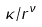Convert formula to latex. <formula><loc_0><loc_0><loc_500><loc_500>\kappa / r ^ { \nu }</formula> 